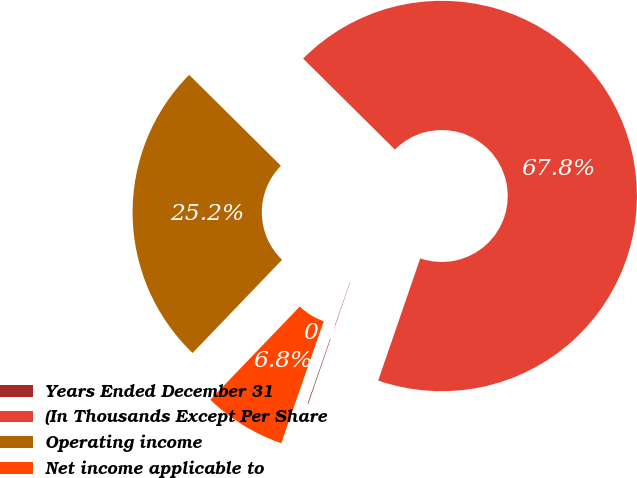<chart> <loc_0><loc_0><loc_500><loc_500><pie_chart><fcel>Years Ended December 31<fcel>(In Thousands Except Per Share<fcel>Operating income<fcel>Net income applicable to<nl><fcel>0.06%<fcel>67.85%<fcel>25.25%<fcel>6.84%<nl></chart> 